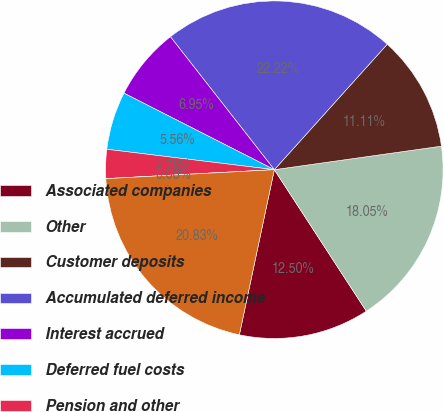<chart> <loc_0><loc_0><loc_500><loc_500><pie_chart><fcel>Associated companies<fcel>Other<fcel>Customer deposits<fcel>Accumulated deferred income<fcel>Interest accrued<fcel>Deferred fuel costs<fcel>Pension and other<fcel>Gas hedge contracts<fcel>TOTAL<nl><fcel>12.5%<fcel>18.05%<fcel>11.11%<fcel>22.22%<fcel>6.95%<fcel>5.56%<fcel>2.78%<fcel>0.0%<fcel>20.83%<nl></chart> 